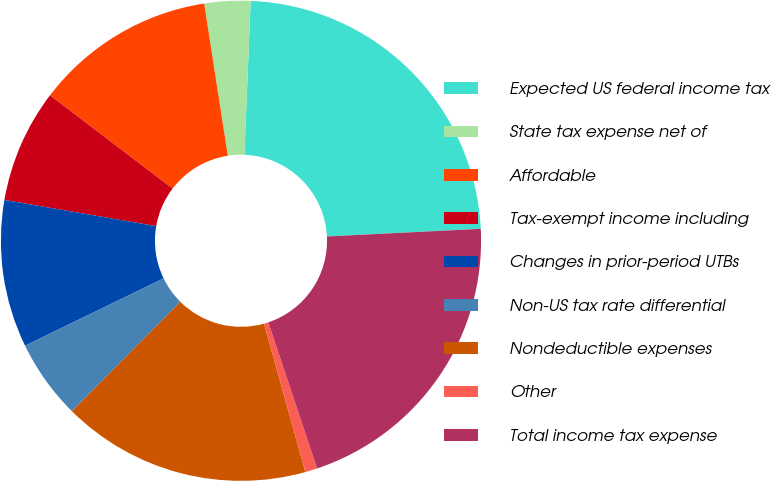<chart> <loc_0><loc_0><loc_500><loc_500><pie_chart><fcel>Expected US federal income tax<fcel>State tax expense net of<fcel>Affordable<fcel>Tax-exempt income including<fcel>Changes in prior-period UTBs<fcel>Non-US tax rate differential<fcel>Nondeductible expenses<fcel>Other<fcel>Total income tax expense<nl><fcel>23.57%<fcel>3.09%<fcel>12.19%<fcel>7.64%<fcel>9.92%<fcel>5.36%<fcel>16.76%<fcel>0.81%<fcel>20.66%<nl></chart> 